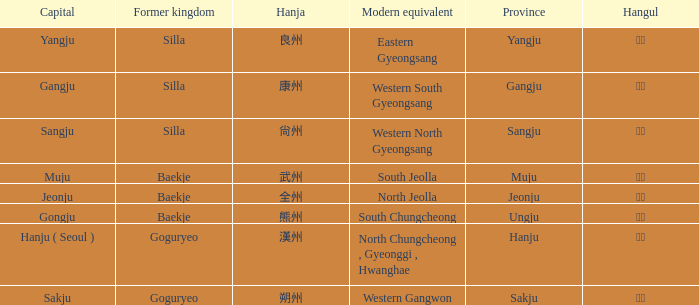What is the hanja for the province of "sangju"? 尙州. Give me the full table as a dictionary. {'header': ['Capital', 'Former kingdom', 'Hanja', 'Modern equivalent', 'Province', 'Hangul'], 'rows': [['Yangju', 'Silla', '良州', 'Eastern Gyeongsang', 'Yangju', '양주'], ['Gangju', 'Silla', '康州', 'Western South Gyeongsang', 'Gangju', '강주'], ['Sangju', 'Silla', '尙州', 'Western North Gyeongsang', 'Sangju', '상주'], ['Muju', 'Baekje', '武州', 'South Jeolla', 'Muju', '무주'], ['Jeonju', 'Baekje', '全州', 'North Jeolla', 'Jeonju', '전주'], ['Gongju', 'Baekje', '熊州', 'South Chungcheong', 'Ungju', '웅주'], ['Hanju ( Seoul )', 'Goguryeo', '漢州', 'North Chungcheong , Gyeonggi , Hwanghae', 'Hanju', '한주'], ['Sakju', 'Goguryeo', '朔州', 'Western Gangwon', 'Sakju', '삭주']]} 